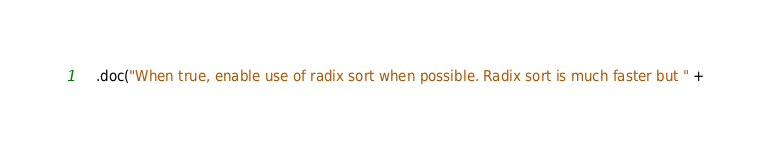<code> <loc_0><loc_0><loc_500><loc_500><_Scala_>    .doc("When true, enable use of radix sort when possible. Radix sort is much faster but " +</code> 